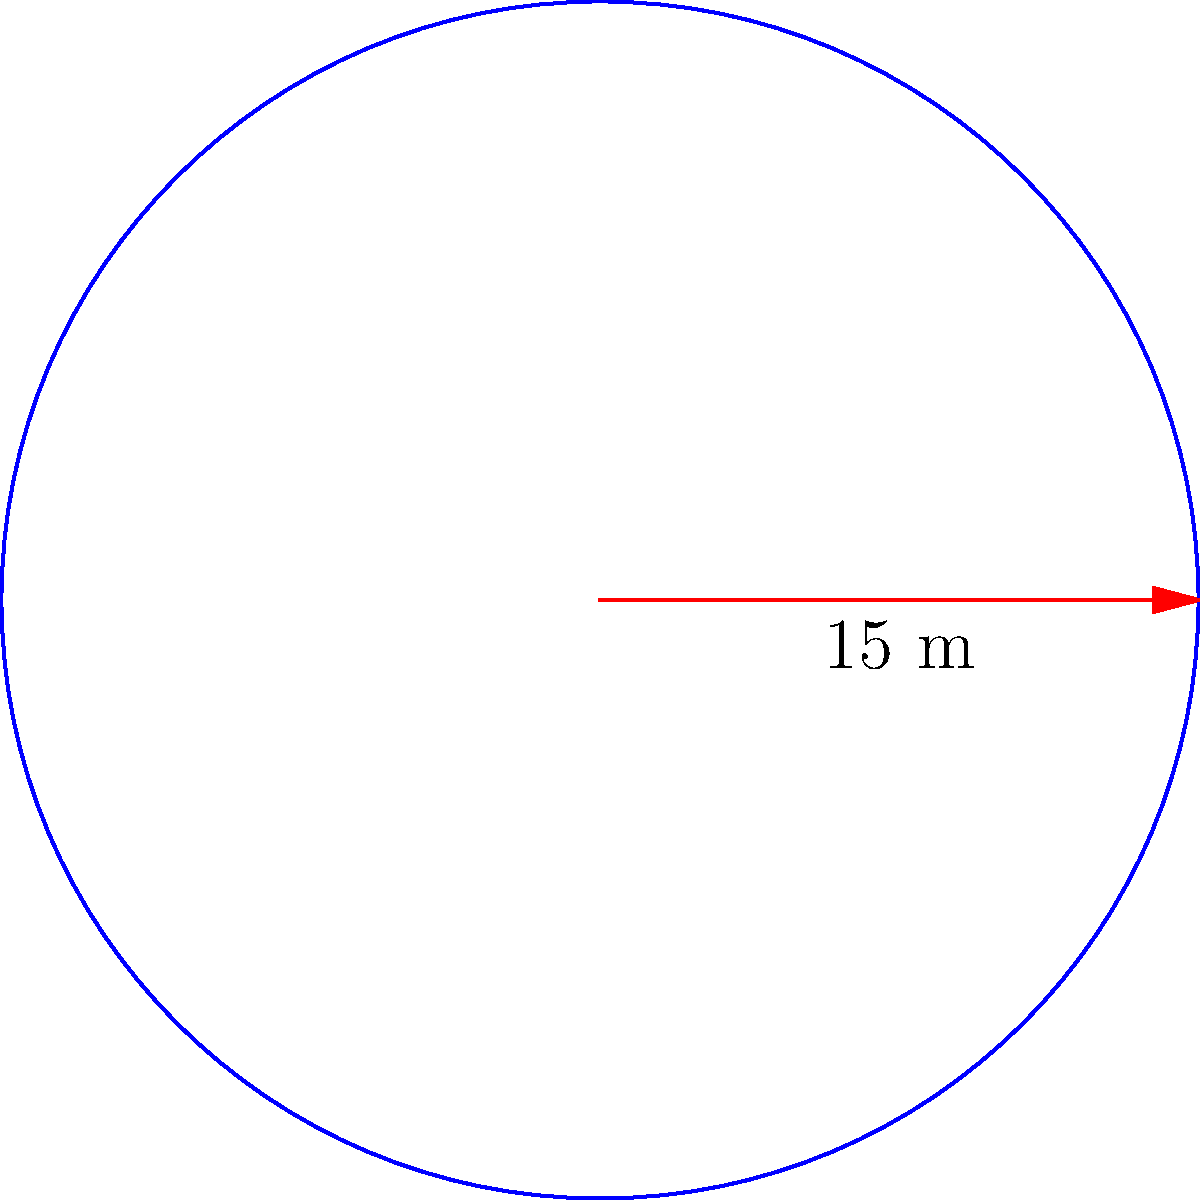A circular community gathering space is being planned for an urban neighborhood in Dhaka. The radius of the space is 15 meters. Calculate the area of this gathering space to determine how many people it can accommodate safely, assuming each person needs 1 square meter of space. To solve this problem, we need to follow these steps:

1. Recall the formula for the area of a circle:
   $$A = \pi r^2$$
   where $A$ is the area and $r$ is the radius.

2. We are given that the radius is 15 meters. Let's substitute this into our formula:
   $$A = \pi (15)^2$$

3. Simplify the expression inside the parentheses:
   $$A = \pi (225)$$

4. Use 3.14 as an approximation for $\pi$:
   $$A \approx 3.14 \times 225$$

5. Calculate the final result:
   $$A \approx 706.5 \text{ square meters}$$

6. Since we're dealing with people, we should round down to the nearest whole number:
   $$A \approx 706 \text{ square meters}$$

Therefore, the gathering space can safely accommodate 706 people, assuming each person needs 1 square meter of space.
Answer: 706 square meters 